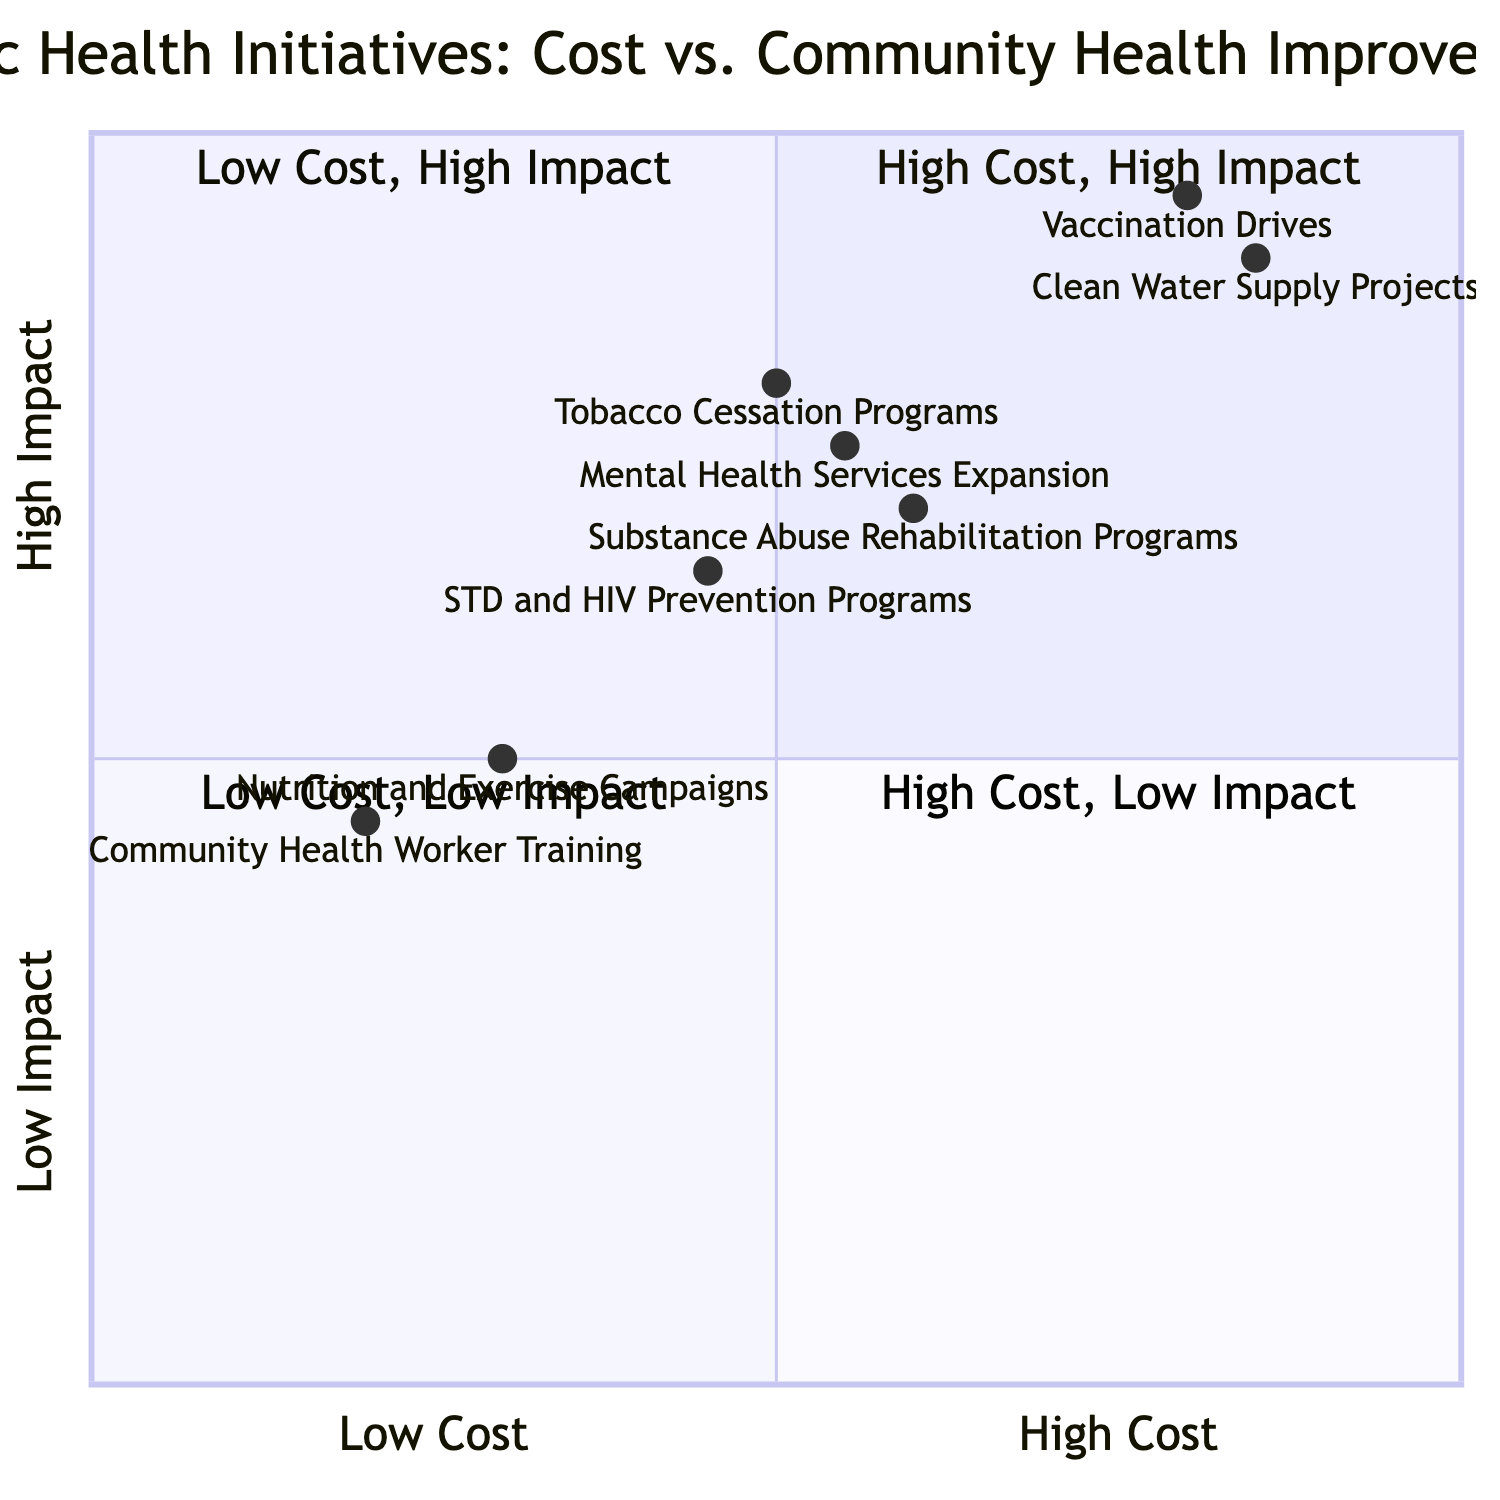What initiative is located in Quadrant 1? Quadrant 1 contains initiatives that have a high cost and a high impact. Looking at the diagram data, the initiatives that fall into this category are "Vaccination Drives" and "Clean Water Supply Projects."
Answer: Vaccination Drives, Clean Water Supply Projects How many initiatives are classified as having high community health improvement? The chart lists the initiatives with "high" or "very high" community health improvement, which are "Vaccination Drives," "Clean Water Supply Projects," "Tobacco Cessation Programs," "Mental Health Services Expansion," "Substance Abuse Rehabilitation Programs," and "STD and HIV Prevention Programs." That's a total of six initiatives.
Answer: 6 Which initiative has the lowest cost? The initiatives with a "low" cost category are "Nutrition and Exercise Campaigns" and "Community Health Worker Training." Out of them, "Community Health Worker Training" has the lowest community health improvement impact, placing it lower in the visual representation.
Answer: Community Health Worker Training What is the community health improvement level of the Nutrition and Exercise Campaigns? The chart specifies that "Nutrition and Exercise Campaigns" have a "medium" community health improvement level, which is indicated in the data provided.
Answer: medium Which initiative is closest to the high end of both cost and community health improvement? Looking at the graph, "Clean Water Supply Projects" and "Vaccination Drives" are positioned at the high end. "Clean Water Supply Projects" is slightly higher in impact compared to "Vaccination Drives." Therefore, it is the closest to the top right corner of the quadrant.
Answer: Clean Water Supply Projects How does the cost of Mental Health Services Expansion compare to Tobacco Cessation Programs? Both initiatives fall into the "medium" cost category, which indicates that they are equivalent in cost according to the diagram.
Answer: same Which initiative is in Quadrant 4? Quadrant 4 is designated for initiatives that have a high cost but low community health improvement. According to the data, there are no initiatives that fall into this quadrant based on the current information.
Answer: None 